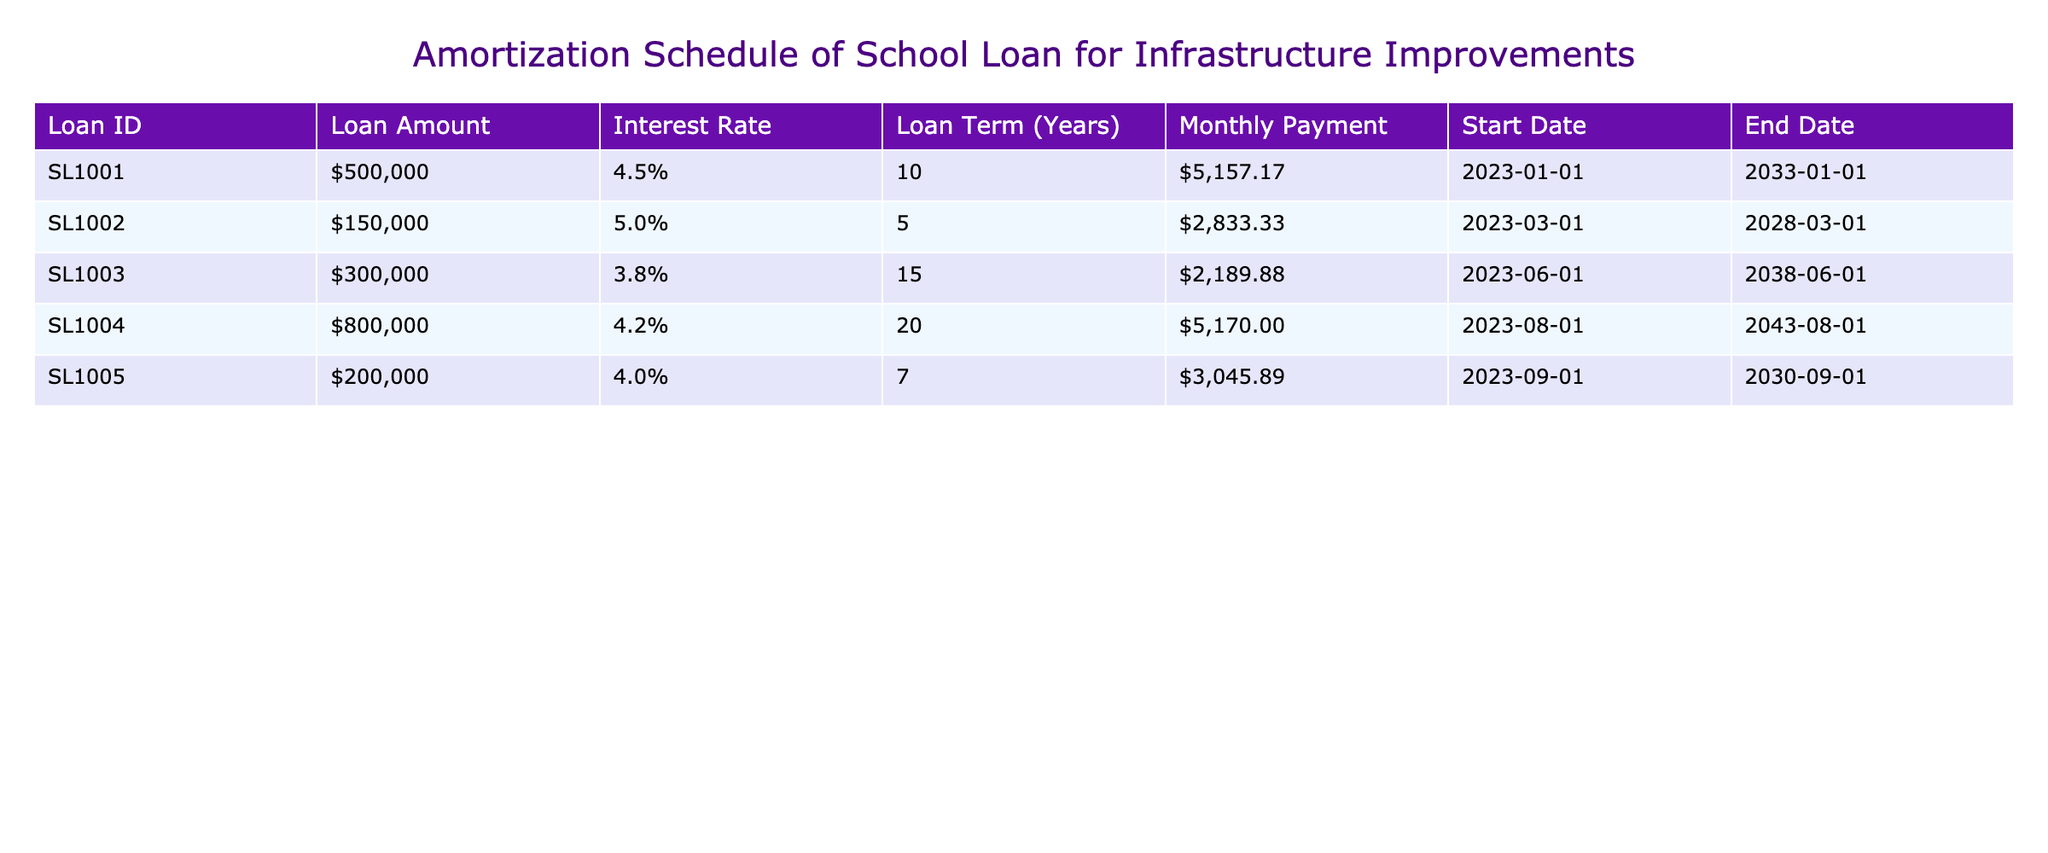What's the loan amount for SL1003? The table lists the loan amounts for each Loan ID. For SL1003, the corresponding loan amount is $300,000.
Answer: $300,000 What is the monthly payment for SL1002? The table shows the monthly payment amount next to SL1002. The monthly payment is $2,833.33.
Answer: $2,833.33 Which loan has the longest term? To find the longest term, compare the "Loan Term (Years)" column. SL1004 has a term of 20 years, which is the highest among the loans listed.
Answer: SL1004 How much do SL1005 and SL1002 loan amounts add up to? First, we locate the loan amounts: SL1005 has $200,000 and SL1002 has $150,000. Adding them gives $200,000 + $150,000 = $350,000.
Answer: $350,000 Is the interest rate for SL1001 lower than 5%? Looking at the interest rate for SL1001, it is 4.5%. Since 4.5% is lower than 5%, the answer is Yes.
Answer: Yes What is the average monthly payment for all loans? We first identify the monthly payments: $5,157.17, $2,833.33, $2,189.88, $5,170.00, and $3,045.89. Summing these gives $18,396.27. Dividing by 5 (the number of loans) results in an average of $3,679.25.
Answer: $3,679.25 Which loan has the highest interest rate? By examining the "Interest Rate" column, SL1002 has an interest rate of 5%, which is the highest compared to the others.
Answer: SL1002 How many loans have a term of more than 10 years? We check each loan term: SL1003, SL1004, and SL1001 have terms longer than 10 years (15, 20, and 10 respectively). Thus, there are three loans meeting this criterion.
Answer: 3 Is the loan amount for SL1004 greater than $700,000? The loan amount for SL1004 is $800,000, which is indeed greater than $700,000. Therefore, the answer is Yes.
Answer: Yes 